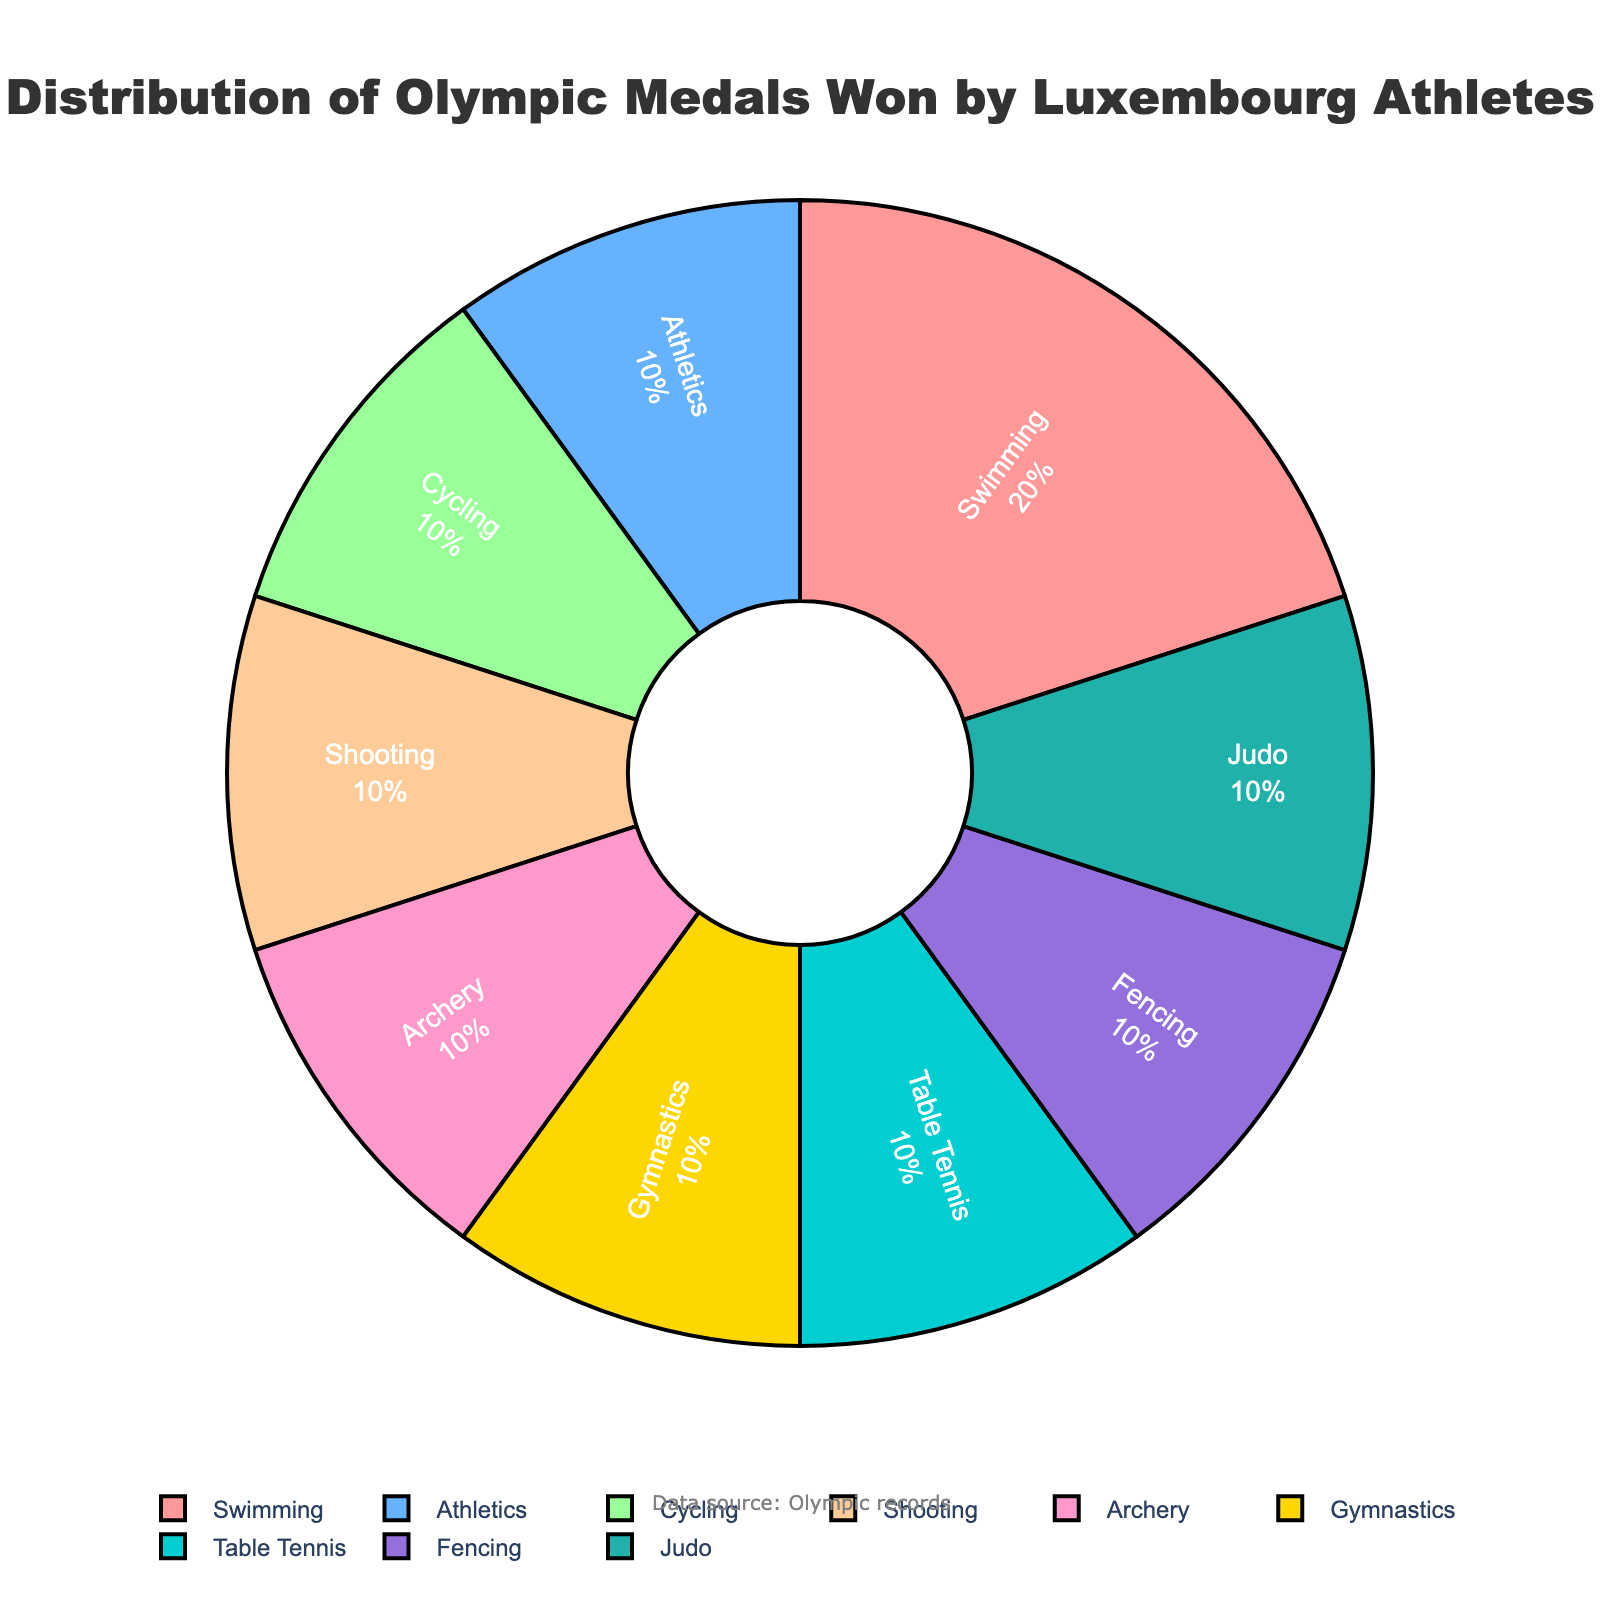Which sport has won the highest number of medals? By looking at the pie chart, the sport with the largest section will have won the most medals. Specifically, we observe that Swimming has 2 medals, which is the highest count compared to other sports.
Answer: Swimming How many total medals have Luxembourg athletes won in Olympic events? To find the total medals, we sum the values of all medal counts shown in the pie chart: 2 (Swimming) + 1 (Athletics) + 1 (Cycling) + 1 (Shooting) + 1 (Archery) + 1 (Gymnastics) + 1 (Table Tennis) + 1 (Fencing) + 1 (Judo) = 10.
Answer: 10 Which sports have an equal number of medals won? By referring to the pie chart, we observe the sections with the same magnitude. Apart from Swimming, all other sports (Athletics, Cycling, Shooting, Archery, Gymnastics, Table Tennis, Fencing, Judo) have 1 medal each.
Answer: Athletics, Cycling, Shooting, Archery, Gymnastics, Table Tennis, Fencing, Judo What is the percentage of medals won in Athletics? The pie chart shows percentages along with the labels. The Athletics portion indicates 10% of the medals, which correlates to 1 out of 10 total medals.
Answer: 10% How does the number of medals in Swimming compare to the number of medals in Cycling? By observing the pie chart, we note that Swimming has 2 medals while Cycling has 1 medal. Hence, Swimming has one more medal than Cycling.
Answer: Swimming has 1 more medal than Cycling How many medals have been won in individual sports (consider sports like Swimming, Athletics, etc.)? Since all listed sports are individual sports, we can sum all the medals: 2 (Swimming) + 1 (Athletics) + 1 (Cycling) + 1 (Shooting) + 1 (Archery) + 1 (Gymnastics) + 1 (Table Tennis) + 1 (Fencing) + 1 (Judo) = 10.
Answer: 10 What is the combined percentage of medals from Swimming and Athletics? From the pie chart, Swimming accounts for 20% and Athletics accounts for 10%. Therefore, the combined percentage is 20% + 10% = 30%.
Answer: 30% Which sports have the smallest wedges in the pie chart and why? The sports with only 1 medal each (Athletics, Cycling, Shooting, Archery, Gymnastics, Table Tennis, Fencing, Judo) have the smallest wedges because they represent the least share of the total medals (10% each).
Answer: Athletics, Cycling, Shooting, Archery, Gymnastics, Table Tennis, Fencing, Judo 